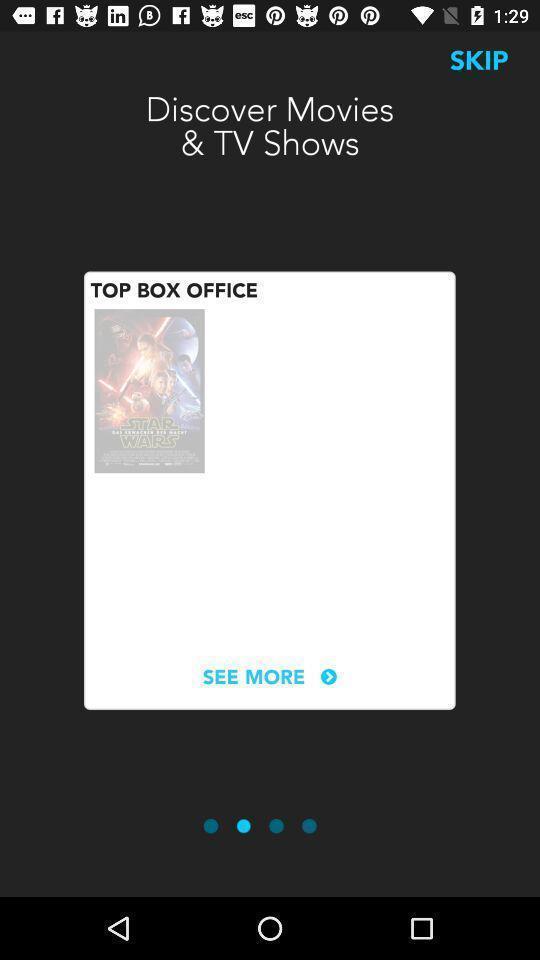Describe the key features of this screenshot. Slide of movie wallpaper in the application. 